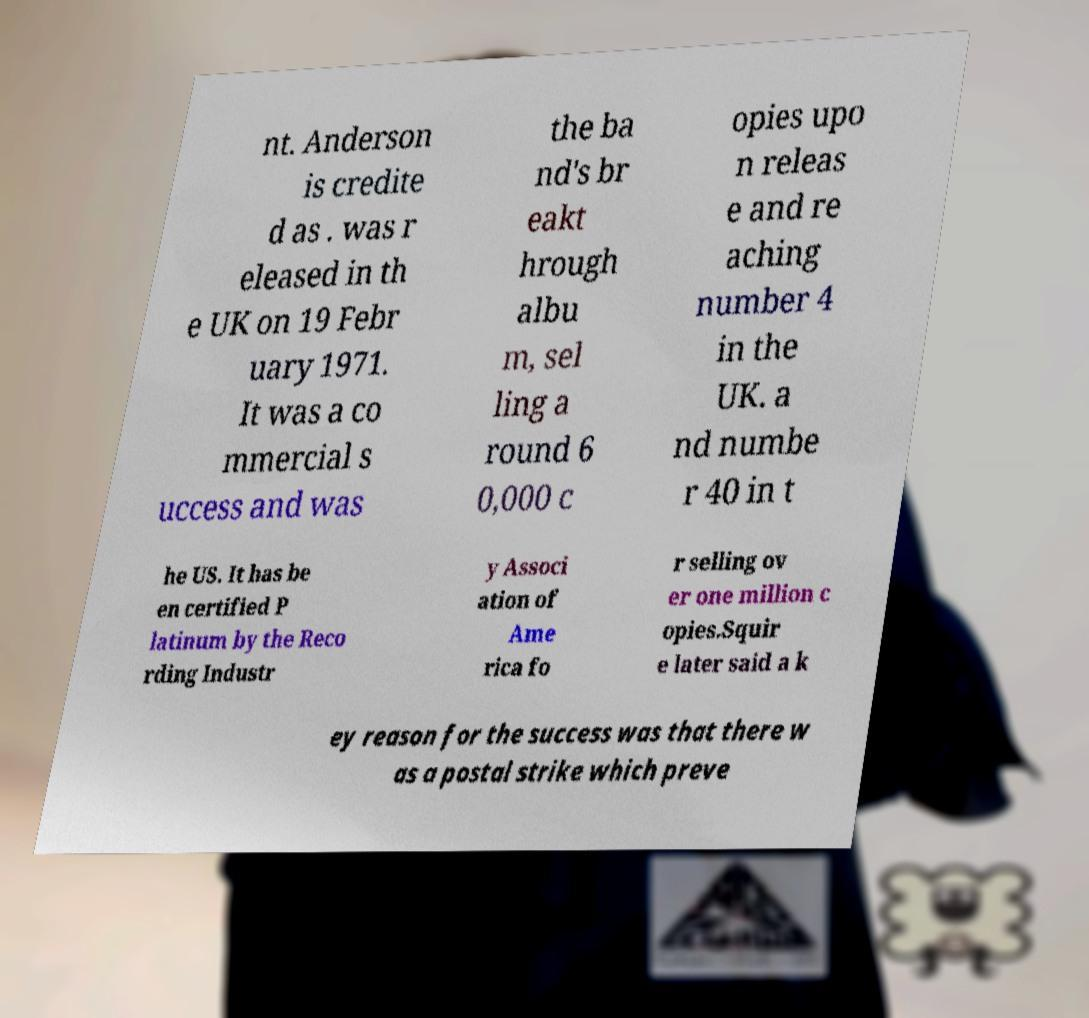Can you read and provide the text displayed in the image?This photo seems to have some interesting text. Can you extract and type it out for me? nt. Anderson is credite d as . was r eleased in th e UK on 19 Febr uary 1971. It was a co mmercial s uccess and was the ba nd's br eakt hrough albu m, sel ling a round 6 0,000 c opies upo n releas e and re aching number 4 in the UK. a nd numbe r 40 in t he US. It has be en certified P latinum by the Reco rding Industr y Associ ation of Ame rica fo r selling ov er one million c opies.Squir e later said a k ey reason for the success was that there w as a postal strike which preve 